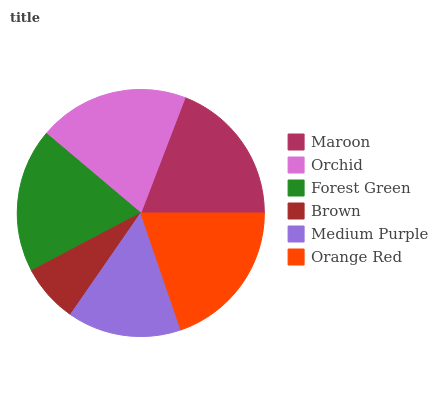Is Brown the minimum?
Answer yes or no. Yes. Is Orange Red the maximum?
Answer yes or no. Yes. Is Orchid the minimum?
Answer yes or no. No. Is Orchid the maximum?
Answer yes or no. No. Is Orchid greater than Maroon?
Answer yes or no. Yes. Is Maroon less than Orchid?
Answer yes or no. Yes. Is Maroon greater than Orchid?
Answer yes or no. No. Is Orchid less than Maroon?
Answer yes or no. No. Is Maroon the high median?
Answer yes or no. Yes. Is Forest Green the low median?
Answer yes or no. Yes. Is Medium Purple the high median?
Answer yes or no. No. Is Maroon the low median?
Answer yes or no. No. 